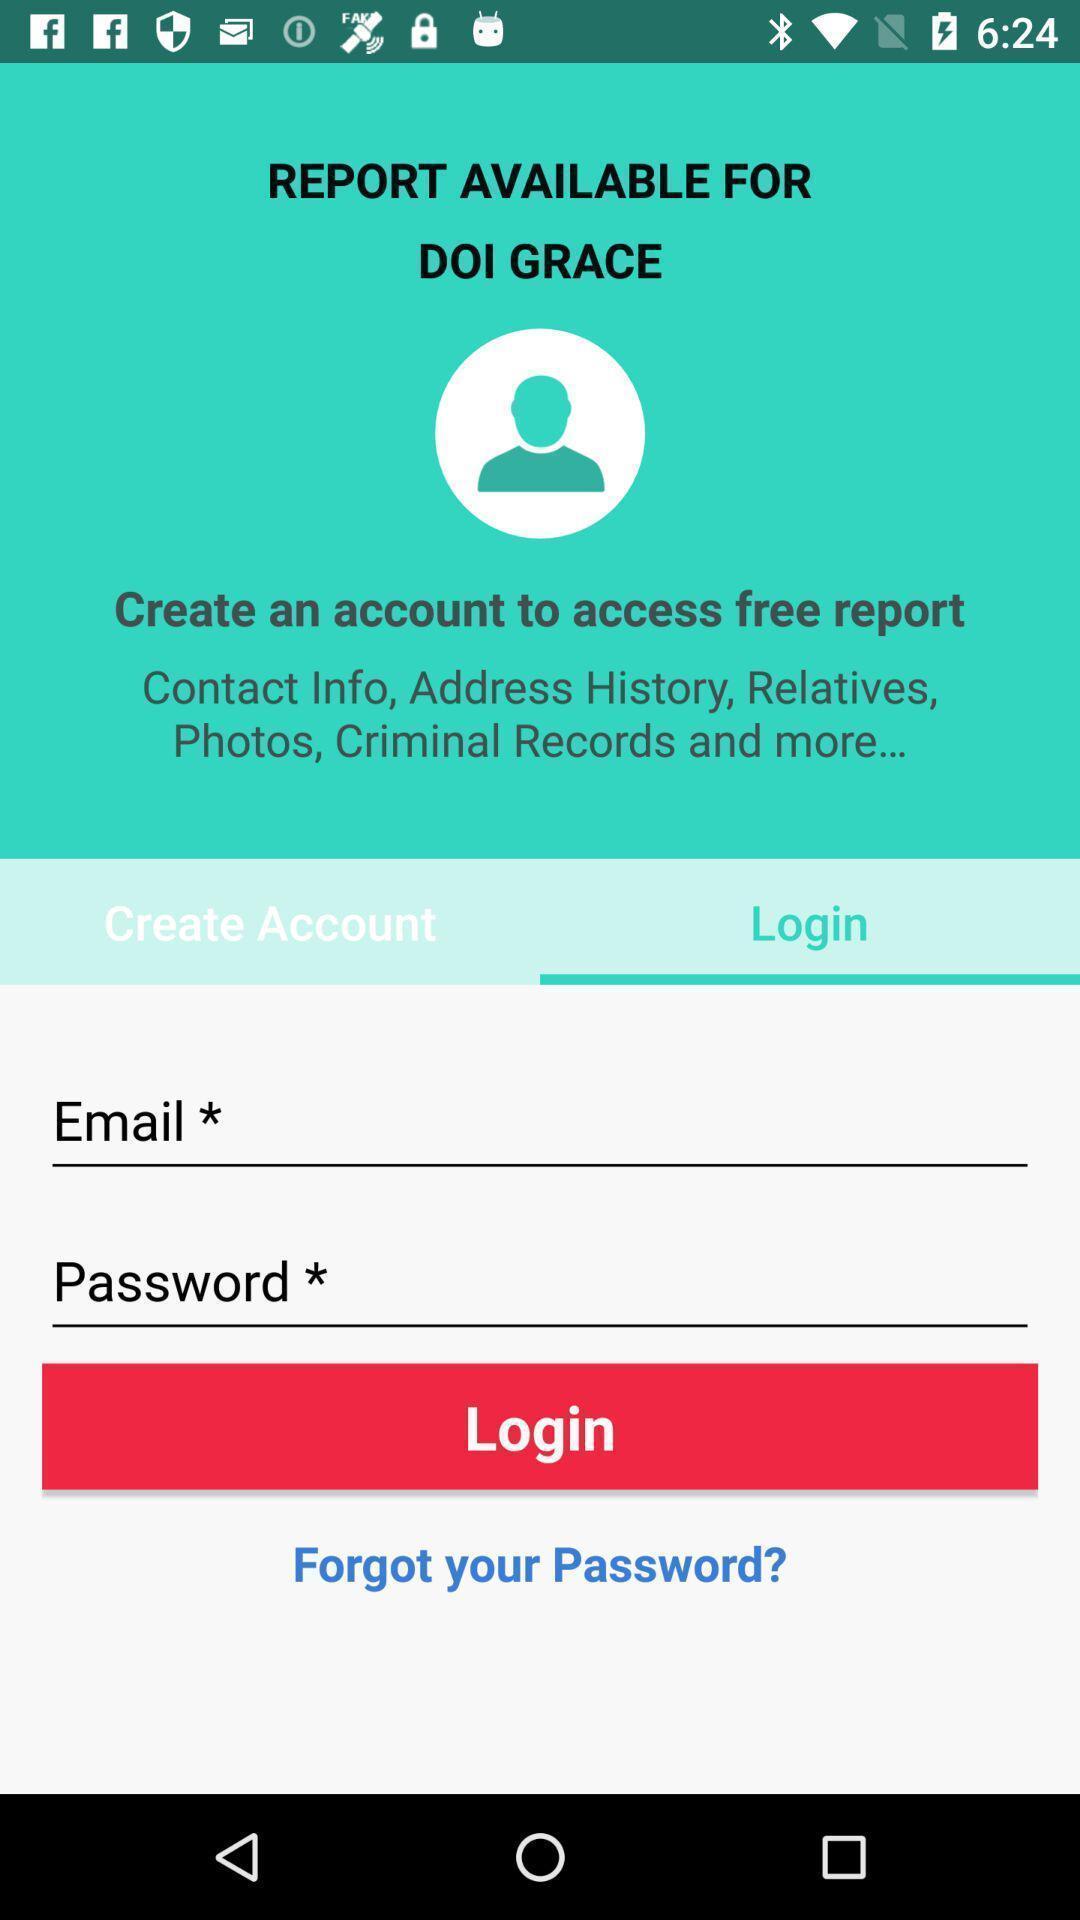What is the overall content of this screenshot? Page displaying login information about people searching application. 